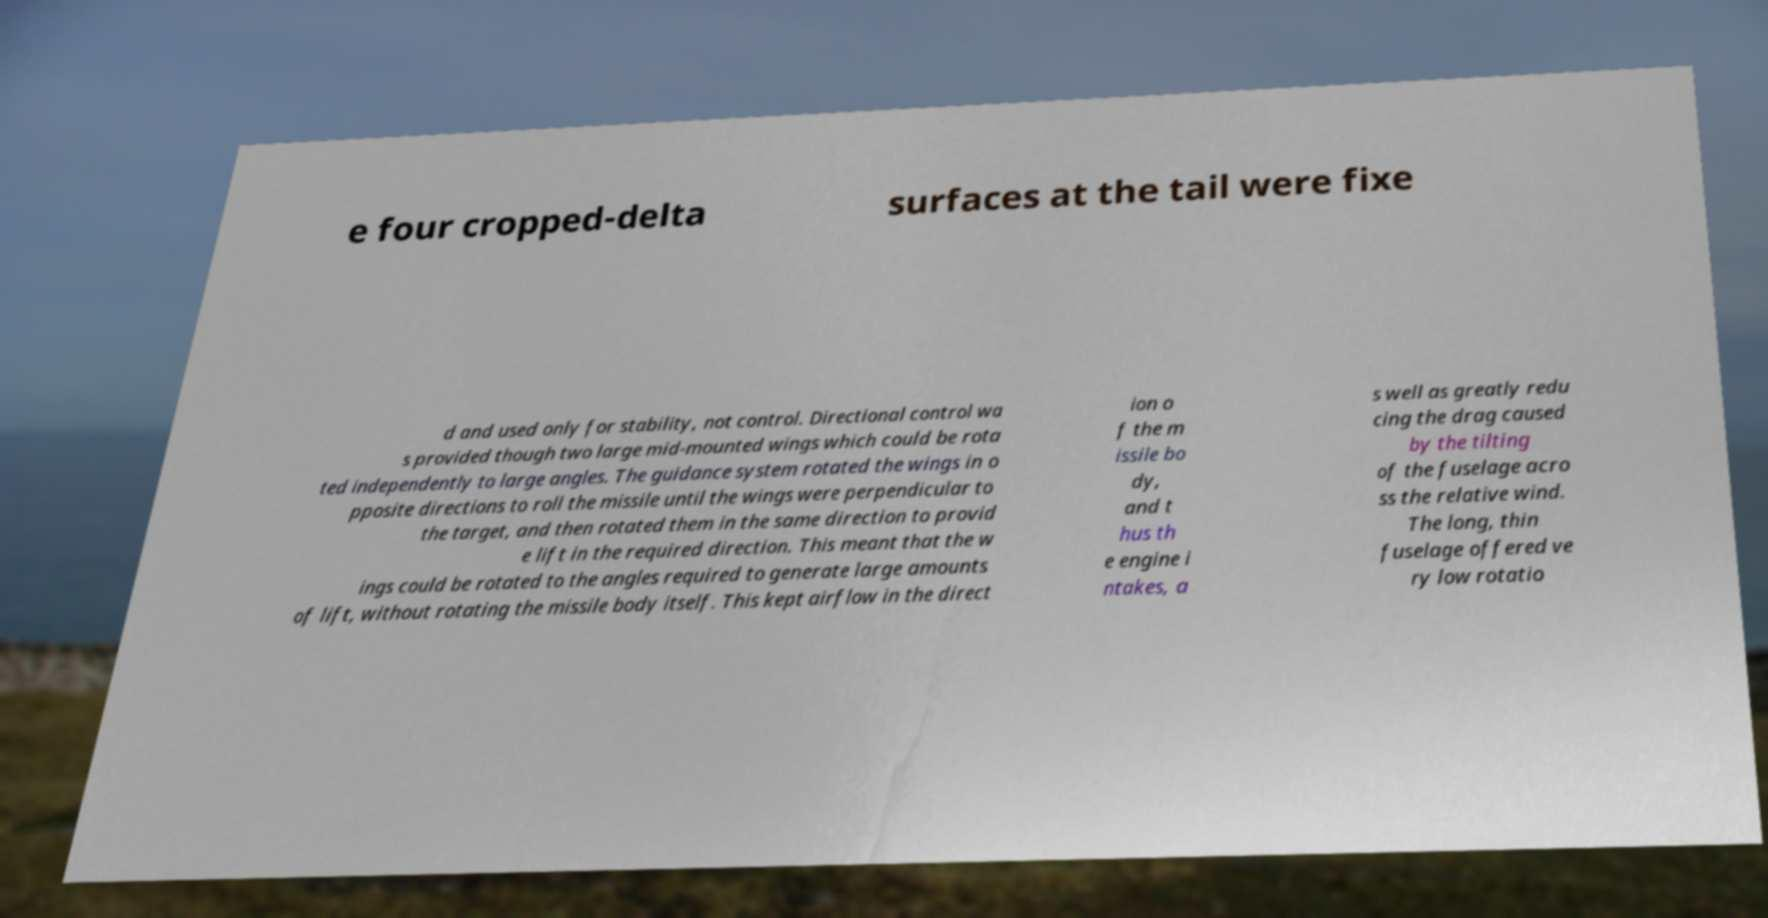I need the written content from this picture converted into text. Can you do that? e four cropped-delta surfaces at the tail were fixe d and used only for stability, not control. Directional control wa s provided though two large mid-mounted wings which could be rota ted independently to large angles. The guidance system rotated the wings in o pposite directions to roll the missile until the wings were perpendicular to the target, and then rotated them in the same direction to provid e lift in the required direction. This meant that the w ings could be rotated to the angles required to generate large amounts of lift, without rotating the missile body itself. This kept airflow in the direct ion o f the m issile bo dy, and t hus th e engine i ntakes, a s well as greatly redu cing the drag caused by the tilting of the fuselage acro ss the relative wind. The long, thin fuselage offered ve ry low rotatio 